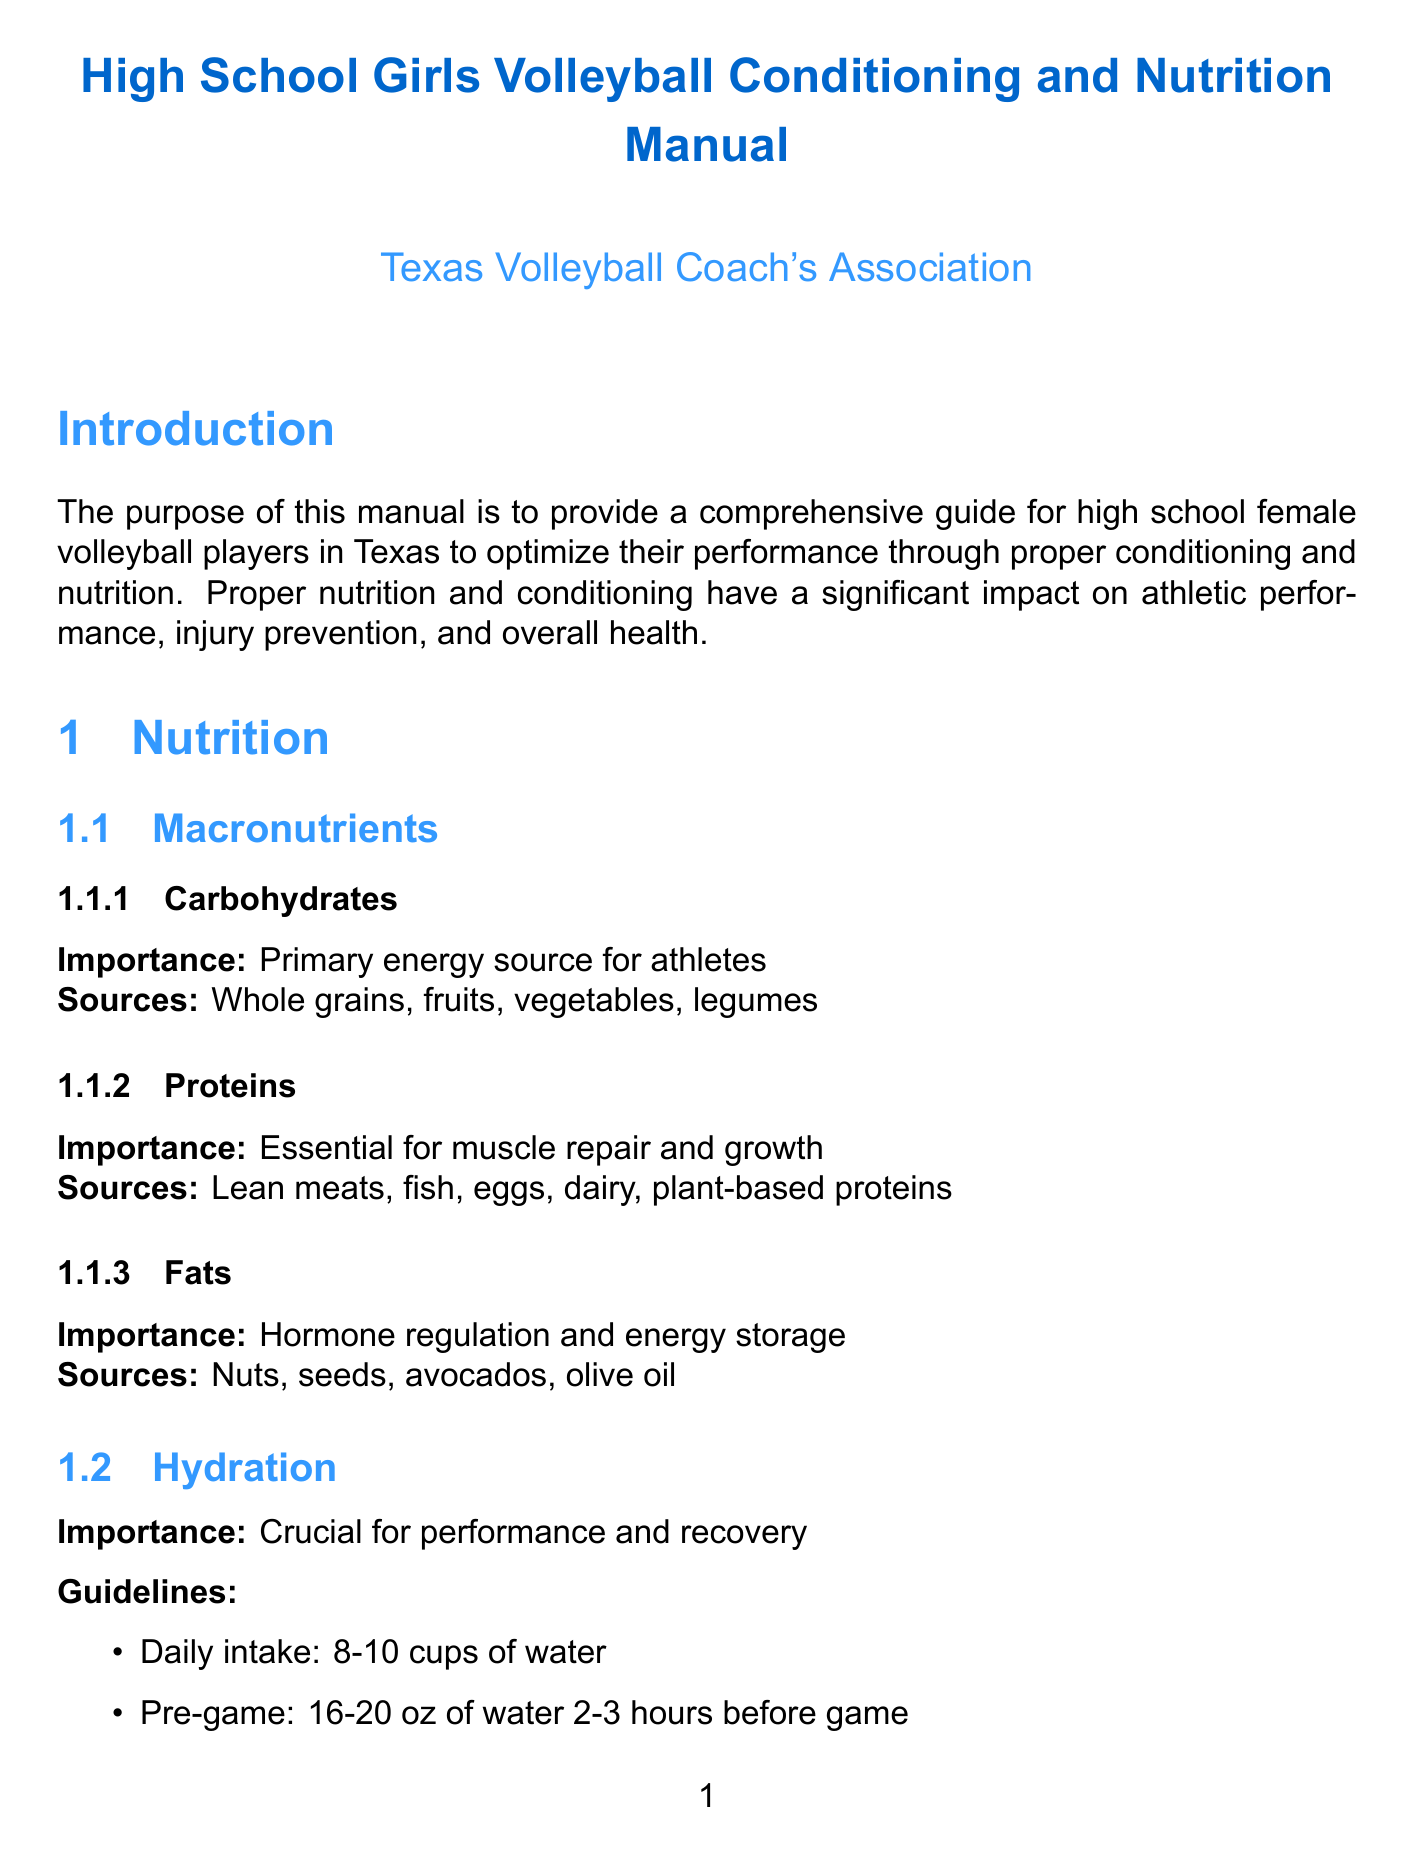What is the primary energy source for athletes? The primary energy source for athletes is carbohydrates.
Answer: carbohydrates How many cups of water should an athlete drink daily? The document specifies that an athlete should drink 8-10 cups of water daily.
Answer: 8-10 cups What is recommended for dinner post-game? The suggested dinner post-game is baked salmon, quinoa, roasted sweet potato, mixed green salad.
Answer: baked salmon, quinoa, roasted sweet potato, mixed green salad How often should strength training be done per week? Strength training should be done 2-3 times per week.
Answer: 2-3 times What is one exercise included in cardiovascular training? One exercise included in cardiovascular training is interval sprints.
Answer: interval sprints What is emphasized for proper technique in injury prevention? Proper technique in injury prevention emphasizes correct form in all volleyball-specific movements.
Answer: correct form in all volleyball-specific movements Which supplement should be consulted with a healthcare professional before starting? It is recommended to consult a healthcare professional before starting any supplement regimen.
Answer: any supplement regimen What is a mental preparation technique mentioned? One mental preparation technique mentioned is visualization.
Answer: visualization 